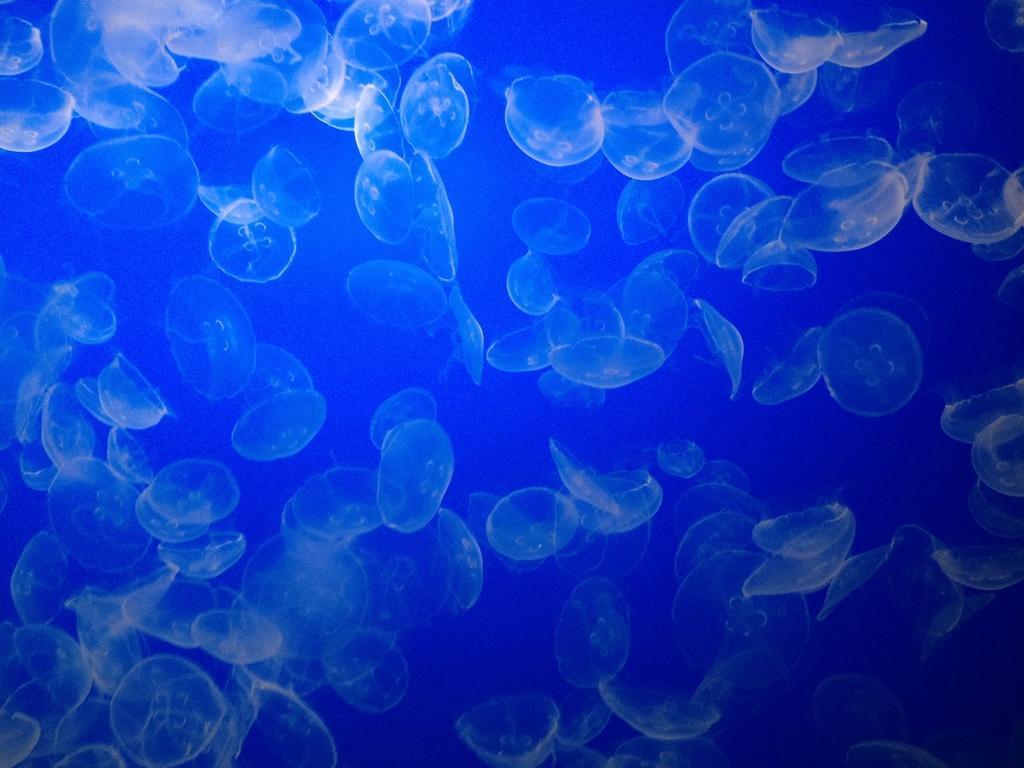Please provide a concise description of this image. In this image we can see fishes in water. 